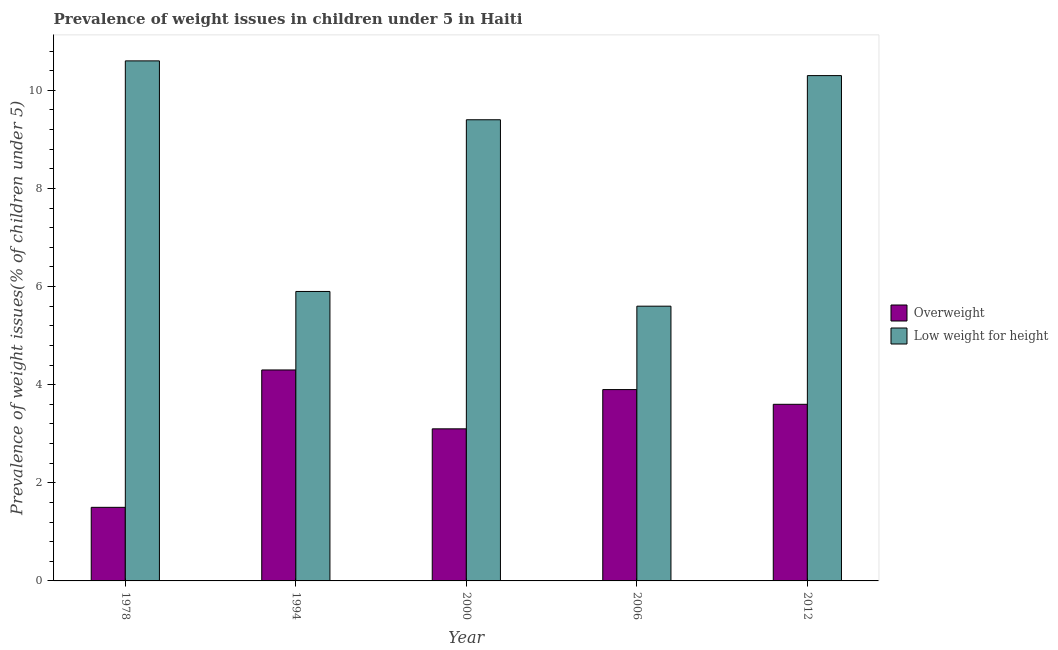How many groups of bars are there?
Ensure brevity in your answer.  5. Are the number of bars on each tick of the X-axis equal?
Your response must be concise. Yes. How many bars are there on the 4th tick from the left?
Your answer should be compact. 2. What is the label of the 3rd group of bars from the left?
Offer a terse response. 2000. What is the percentage of overweight children in 2006?
Ensure brevity in your answer.  3.9. Across all years, what is the maximum percentage of underweight children?
Offer a very short reply. 10.6. Across all years, what is the minimum percentage of underweight children?
Make the answer very short. 5.6. In which year was the percentage of underweight children minimum?
Offer a very short reply. 2006. What is the total percentage of overweight children in the graph?
Provide a short and direct response. 16.4. What is the difference between the percentage of underweight children in 2006 and that in 2012?
Give a very brief answer. -4.7. What is the difference between the percentage of overweight children in 1978 and the percentage of underweight children in 2012?
Your answer should be compact. -2.1. What is the average percentage of overweight children per year?
Provide a succinct answer. 3.28. In the year 2006, what is the difference between the percentage of underweight children and percentage of overweight children?
Your answer should be compact. 0. What is the ratio of the percentage of overweight children in 1994 to that in 2006?
Give a very brief answer. 1.1. Is the percentage of underweight children in 1994 less than that in 2012?
Make the answer very short. Yes. What is the difference between the highest and the second highest percentage of underweight children?
Provide a short and direct response. 0.3. What is the difference between the highest and the lowest percentage of overweight children?
Your answer should be very brief. 2.8. In how many years, is the percentage of underweight children greater than the average percentage of underweight children taken over all years?
Your response must be concise. 3. What does the 1st bar from the left in 2006 represents?
Ensure brevity in your answer.  Overweight. What does the 1st bar from the right in 1994 represents?
Keep it short and to the point. Low weight for height. Are all the bars in the graph horizontal?
Provide a succinct answer. No. How many years are there in the graph?
Ensure brevity in your answer.  5. Does the graph contain any zero values?
Offer a very short reply. No. How are the legend labels stacked?
Keep it short and to the point. Vertical. What is the title of the graph?
Ensure brevity in your answer.  Prevalence of weight issues in children under 5 in Haiti. Does "Males" appear as one of the legend labels in the graph?
Your answer should be compact. No. What is the label or title of the X-axis?
Ensure brevity in your answer.  Year. What is the label or title of the Y-axis?
Your answer should be compact. Prevalence of weight issues(% of children under 5). What is the Prevalence of weight issues(% of children under 5) in Low weight for height in 1978?
Offer a terse response. 10.6. What is the Prevalence of weight issues(% of children under 5) in Overweight in 1994?
Offer a terse response. 4.3. What is the Prevalence of weight issues(% of children under 5) of Low weight for height in 1994?
Make the answer very short. 5.9. What is the Prevalence of weight issues(% of children under 5) in Overweight in 2000?
Offer a very short reply. 3.1. What is the Prevalence of weight issues(% of children under 5) of Low weight for height in 2000?
Ensure brevity in your answer.  9.4. What is the Prevalence of weight issues(% of children under 5) of Overweight in 2006?
Offer a terse response. 3.9. What is the Prevalence of weight issues(% of children under 5) of Low weight for height in 2006?
Ensure brevity in your answer.  5.6. What is the Prevalence of weight issues(% of children under 5) of Overweight in 2012?
Offer a terse response. 3.6. What is the Prevalence of weight issues(% of children under 5) in Low weight for height in 2012?
Offer a very short reply. 10.3. Across all years, what is the maximum Prevalence of weight issues(% of children under 5) of Overweight?
Provide a short and direct response. 4.3. Across all years, what is the maximum Prevalence of weight issues(% of children under 5) in Low weight for height?
Make the answer very short. 10.6. Across all years, what is the minimum Prevalence of weight issues(% of children under 5) in Low weight for height?
Keep it short and to the point. 5.6. What is the total Prevalence of weight issues(% of children under 5) in Overweight in the graph?
Ensure brevity in your answer.  16.4. What is the total Prevalence of weight issues(% of children under 5) of Low weight for height in the graph?
Keep it short and to the point. 41.8. What is the difference between the Prevalence of weight issues(% of children under 5) in Low weight for height in 1978 and that in 1994?
Give a very brief answer. 4.7. What is the difference between the Prevalence of weight issues(% of children under 5) of Overweight in 1978 and that in 2000?
Offer a terse response. -1.6. What is the difference between the Prevalence of weight issues(% of children under 5) of Low weight for height in 1978 and that in 2000?
Your response must be concise. 1.2. What is the difference between the Prevalence of weight issues(% of children under 5) of Low weight for height in 1978 and that in 2006?
Provide a short and direct response. 5. What is the difference between the Prevalence of weight issues(% of children under 5) of Overweight in 1994 and that in 2006?
Give a very brief answer. 0.4. What is the difference between the Prevalence of weight issues(% of children under 5) of Overweight in 2000 and that in 2006?
Ensure brevity in your answer.  -0.8. What is the difference between the Prevalence of weight issues(% of children under 5) in Overweight in 1994 and the Prevalence of weight issues(% of children under 5) in Low weight for height in 2000?
Ensure brevity in your answer.  -5.1. What is the difference between the Prevalence of weight issues(% of children under 5) of Overweight in 1994 and the Prevalence of weight issues(% of children under 5) of Low weight for height in 2006?
Ensure brevity in your answer.  -1.3. What is the difference between the Prevalence of weight issues(% of children under 5) in Overweight in 2000 and the Prevalence of weight issues(% of children under 5) in Low weight for height in 2006?
Offer a terse response. -2.5. What is the difference between the Prevalence of weight issues(% of children under 5) of Overweight in 2000 and the Prevalence of weight issues(% of children under 5) of Low weight for height in 2012?
Keep it short and to the point. -7.2. What is the difference between the Prevalence of weight issues(% of children under 5) in Overweight in 2006 and the Prevalence of weight issues(% of children under 5) in Low weight for height in 2012?
Offer a very short reply. -6.4. What is the average Prevalence of weight issues(% of children under 5) of Overweight per year?
Give a very brief answer. 3.28. What is the average Prevalence of weight issues(% of children under 5) of Low weight for height per year?
Give a very brief answer. 8.36. In the year 2000, what is the difference between the Prevalence of weight issues(% of children under 5) of Overweight and Prevalence of weight issues(% of children under 5) of Low weight for height?
Offer a very short reply. -6.3. What is the ratio of the Prevalence of weight issues(% of children under 5) in Overweight in 1978 to that in 1994?
Your response must be concise. 0.35. What is the ratio of the Prevalence of weight issues(% of children under 5) of Low weight for height in 1978 to that in 1994?
Give a very brief answer. 1.8. What is the ratio of the Prevalence of weight issues(% of children under 5) of Overweight in 1978 to that in 2000?
Offer a terse response. 0.48. What is the ratio of the Prevalence of weight issues(% of children under 5) of Low weight for height in 1978 to that in 2000?
Your answer should be very brief. 1.13. What is the ratio of the Prevalence of weight issues(% of children under 5) of Overweight in 1978 to that in 2006?
Give a very brief answer. 0.38. What is the ratio of the Prevalence of weight issues(% of children under 5) of Low weight for height in 1978 to that in 2006?
Provide a short and direct response. 1.89. What is the ratio of the Prevalence of weight issues(% of children under 5) in Overweight in 1978 to that in 2012?
Provide a succinct answer. 0.42. What is the ratio of the Prevalence of weight issues(% of children under 5) in Low weight for height in 1978 to that in 2012?
Your answer should be very brief. 1.03. What is the ratio of the Prevalence of weight issues(% of children under 5) of Overweight in 1994 to that in 2000?
Offer a very short reply. 1.39. What is the ratio of the Prevalence of weight issues(% of children under 5) of Low weight for height in 1994 to that in 2000?
Offer a very short reply. 0.63. What is the ratio of the Prevalence of weight issues(% of children under 5) in Overweight in 1994 to that in 2006?
Keep it short and to the point. 1.1. What is the ratio of the Prevalence of weight issues(% of children under 5) in Low weight for height in 1994 to that in 2006?
Provide a succinct answer. 1.05. What is the ratio of the Prevalence of weight issues(% of children under 5) in Overweight in 1994 to that in 2012?
Your answer should be compact. 1.19. What is the ratio of the Prevalence of weight issues(% of children under 5) in Low weight for height in 1994 to that in 2012?
Offer a terse response. 0.57. What is the ratio of the Prevalence of weight issues(% of children under 5) in Overweight in 2000 to that in 2006?
Your answer should be compact. 0.79. What is the ratio of the Prevalence of weight issues(% of children under 5) of Low weight for height in 2000 to that in 2006?
Your answer should be compact. 1.68. What is the ratio of the Prevalence of weight issues(% of children under 5) of Overweight in 2000 to that in 2012?
Provide a short and direct response. 0.86. What is the ratio of the Prevalence of weight issues(% of children under 5) of Low weight for height in 2000 to that in 2012?
Provide a short and direct response. 0.91. What is the ratio of the Prevalence of weight issues(% of children under 5) of Overweight in 2006 to that in 2012?
Make the answer very short. 1.08. What is the ratio of the Prevalence of weight issues(% of children under 5) of Low weight for height in 2006 to that in 2012?
Give a very brief answer. 0.54. What is the difference between the highest and the second highest Prevalence of weight issues(% of children under 5) of Low weight for height?
Offer a very short reply. 0.3. What is the difference between the highest and the lowest Prevalence of weight issues(% of children under 5) of Overweight?
Provide a short and direct response. 2.8. 